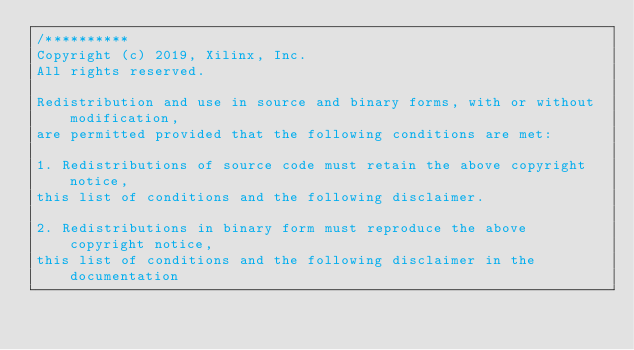Convert code to text. <code><loc_0><loc_0><loc_500><loc_500><_C_>/**********
Copyright (c) 2019, Xilinx, Inc.
All rights reserved.

Redistribution and use in source and binary forms, with or without modification,
are permitted provided that the following conditions are met:

1. Redistributions of source code must retain the above copyright notice,
this list of conditions and the following disclaimer.

2. Redistributions in binary form must reproduce the above copyright notice,
this list of conditions and the following disclaimer in the documentation</code> 